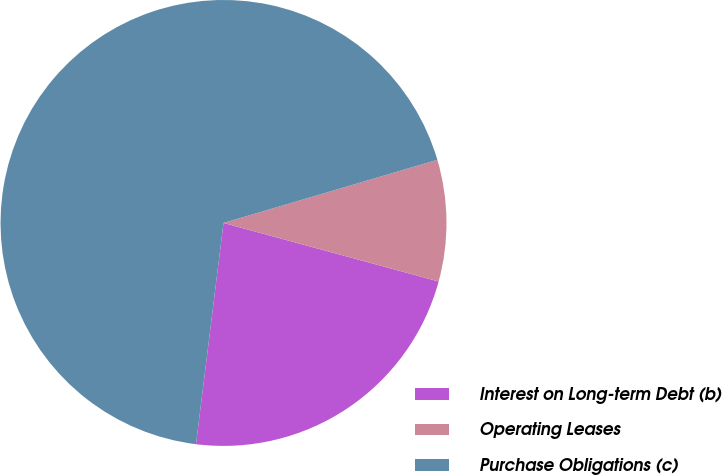Convert chart to OTSL. <chart><loc_0><loc_0><loc_500><loc_500><pie_chart><fcel>Interest on Long-term Debt (b)<fcel>Operating Leases<fcel>Purchase Obligations (c)<nl><fcel>22.74%<fcel>8.8%<fcel>68.46%<nl></chart> 